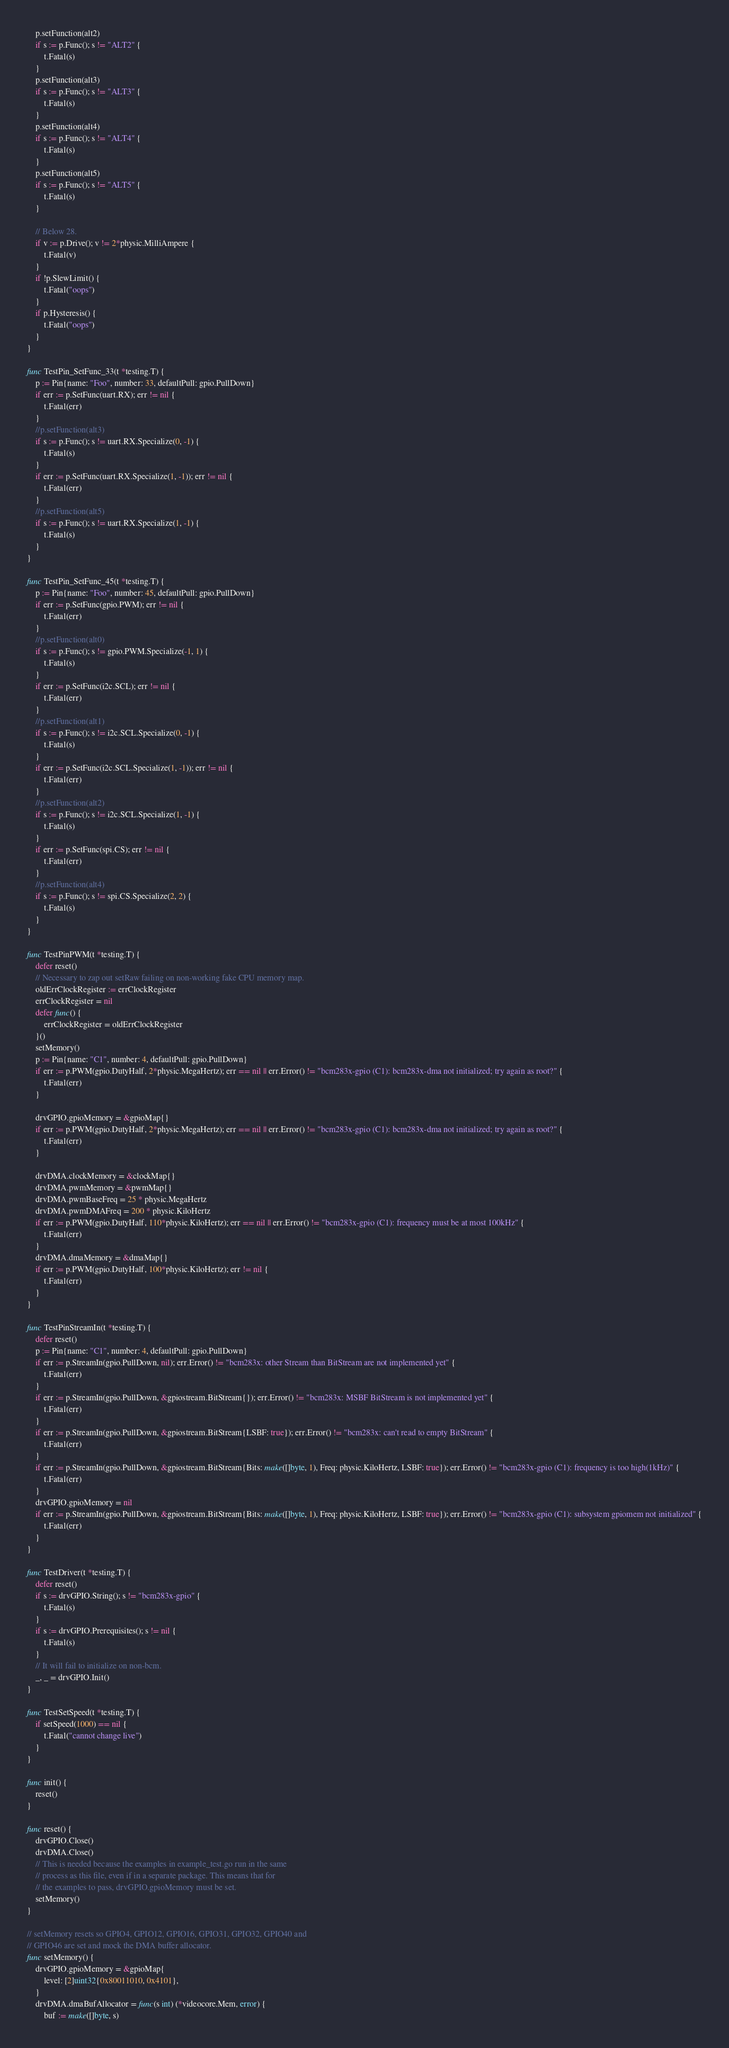<code> <loc_0><loc_0><loc_500><loc_500><_Go_>	p.setFunction(alt2)
	if s := p.Func(); s != "ALT2" {
		t.Fatal(s)
	}
	p.setFunction(alt3)
	if s := p.Func(); s != "ALT3" {
		t.Fatal(s)
	}
	p.setFunction(alt4)
	if s := p.Func(); s != "ALT4" {
		t.Fatal(s)
	}
	p.setFunction(alt5)
	if s := p.Func(); s != "ALT5" {
		t.Fatal(s)
	}

	// Below 28.
	if v := p.Drive(); v != 2*physic.MilliAmpere {
		t.Fatal(v)
	}
	if !p.SlewLimit() {
		t.Fatal("oops")
	}
	if p.Hysteresis() {
		t.Fatal("oops")
	}
}

func TestPin_SetFunc_33(t *testing.T) {
	p := Pin{name: "Foo", number: 33, defaultPull: gpio.PullDown}
	if err := p.SetFunc(uart.RX); err != nil {
		t.Fatal(err)
	}
	//p.setFunction(alt3)
	if s := p.Func(); s != uart.RX.Specialize(0, -1) {
		t.Fatal(s)
	}
	if err := p.SetFunc(uart.RX.Specialize(1, -1)); err != nil {
		t.Fatal(err)
	}
	//p.setFunction(alt5)
	if s := p.Func(); s != uart.RX.Specialize(1, -1) {
		t.Fatal(s)
	}
}

func TestPin_SetFunc_45(t *testing.T) {
	p := Pin{name: "Foo", number: 45, defaultPull: gpio.PullDown}
	if err := p.SetFunc(gpio.PWM); err != nil {
		t.Fatal(err)
	}
	//p.setFunction(alt0)
	if s := p.Func(); s != gpio.PWM.Specialize(-1, 1) {
		t.Fatal(s)
	}
	if err := p.SetFunc(i2c.SCL); err != nil {
		t.Fatal(err)
	}
	//p.setFunction(alt1)
	if s := p.Func(); s != i2c.SCL.Specialize(0, -1) {
		t.Fatal(s)
	}
	if err := p.SetFunc(i2c.SCL.Specialize(1, -1)); err != nil {
		t.Fatal(err)
	}
	//p.setFunction(alt2)
	if s := p.Func(); s != i2c.SCL.Specialize(1, -1) {
		t.Fatal(s)
	}
	if err := p.SetFunc(spi.CS); err != nil {
		t.Fatal(err)
	}
	//p.setFunction(alt4)
	if s := p.Func(); s != spi.CS.Specialize(2, 2) {
		t.Fatal(s)
	}
}

func TestPinPWM(t *testing.T) {
	defer reset()
	// Necessary to zap out setRaw failing on non-working fake CPU memory map.
	oldErrClockRegister := errClockRegister
	errClockRegister = nil
	defer func() {
		errClockRegister = oldErrClockRegister
	}()
	setMemory()
	p := Pin{name: "C1", number: 4, defaultPull: gpio.PullDown}
	if err := p.PWM(gpio.DutyHalf, 2*physic.MegaHertz); err == nil || err.Error() != "bcm283x-gpio (C1): bcm283x-dma not initialized; try again as root?" {
		t.Fatal(err)
	}

	drvGPIO.gpioMemory = &gpioMap{}
	if err := p.PWM(gpio.DutyHalf, 2*physic.MegaHertz); err == nil || err.Error() != "bcm283x-gpio (C1): bcm283x-dma not initialized; try again as root?" {
		t.Fatal(err)
	}

	drvDMA.clockMemory = &clockMap{}
	drvDMA.pwmMemory = &pwmMap{}
	drvDMA.pwmBaseFreq = 25 * physic.MegaHertz
	drvDMA.pwmDMAFreq = 200 * physic.KiloHertz
	if err := p.PWM(gpio.DutyHalf, 110*physic.KiloHertz); err == nil || err.Error() != "bcm283x-gpio (C1): frequency must be at most 100kHz" {
		t.Fatal(err)
	}
	drvDMA.dmaMemory = &dmaMap{}
	if err := p.PWM(gpio.DutyHalf, 100*physic.KiloHertz); err != nil {
		t.Fatal(err)
	}
}

func TestPinStreamIn(t *testing.T) {
	defer reset()
	p := Pin{name: "C1", number: 4, defaultPull: gpio.PullDown}
	if err := p.StreamIn(gpio.PullDown, nil); err.Error() != "bcm283x: other Stream than BitStream are not implemented yet" {
		t.Fatal(err)
	}
	if err := p.StreamIn(gpio.PullDown, &gpiostream.BitStream{}); err.Error() != "bcm283x: MSBF BitStream is not implemented yet" {
		t.Fatal(err)
	}
	if err := p.StreamIn(gpio.PullDown, &gpiostream.BitStream{LSBF: true}); err.Error() != "bcm283x: can't read to empty BitStream" {
		t.Fatal(err)
	}
	if err := p.StreamIn(gpio.PullDown, &gpiostream.BitStream{Bits: make([]byte, 1), Freq: physic.KiloHertz, LSBF: true}); err.Error() != "bcm283x-gpio (C1): frequency is too high(1kHz)" {
		t.Fatal(err)
	}
	drvGPIO.gpioMemory = nil
	if err := p.StreamIn(gpio.PullDown, &gpiostream.BitStream{Bits: make([]byte, 1), Freq: physic.KiloHertz, LSBF: true}); err.Error() != "bcm283x-gpio (C1): subsystem gpiomem not initialized" {
		t.Fatal(err)
	}
}

func TestDriver(t *testing.T) {
	defer reset()
	if s := drvGPIO.String(); s != "bcm283x-gpio" {
		t.Fatal(s)
	}
	if s := drvGPIO.Prerequisites(); s != nil {
		t.Fatal(s)
	}
	// It will fail to initialize on non-bcm.
	_, _ = drvGPIO.Init()
}

func TestSetSpeed(t *testing.T) {
	if setSpeed(1000) == nil {
		t.Fatal("cannot change live")
	}
}

func init() {
	reset()
}

func reset() {
	drvGPIO.Close()
	drvDMA.Close()
	// This is needed because the examples in example_test.go run in the same
	// process as this file, even if in a separate package. This means that for
	// the examples to pass, drvGPIO.gpioMemory must be set.
	setMemory()
}

// setMemory resets so GPIO4, GPIO12, GPIO16, GPIO31, GPIO32, GPIO40 and
// GPIO46 are set and mock the DMA buffer allocator.
func setMemory() {
	drvGPIO.gpioMemory = &gpioMap{
		level: [2]uint32{0x80011010, 0x4101},
	}
	drvDMA.dmaBufAllocator = func(s int) (*videocore.Mem, error) {
		buf := make([]byte, s)</code> 